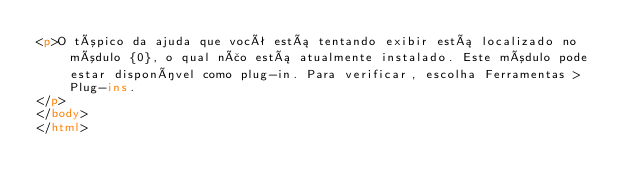Convert code to text. <code><loc_0><loc_0><loc_500><loc_500><_HTML_><p>O tópico da ajuda que você está tentando exibir está localizado no módulo {0}, o qual não está atualmente instalado. Este módulo pode estar disponível como plug-in. Para verificar, escolha Ferramentas > Plug-ins.
</p>
</body>
</html>
</code> 